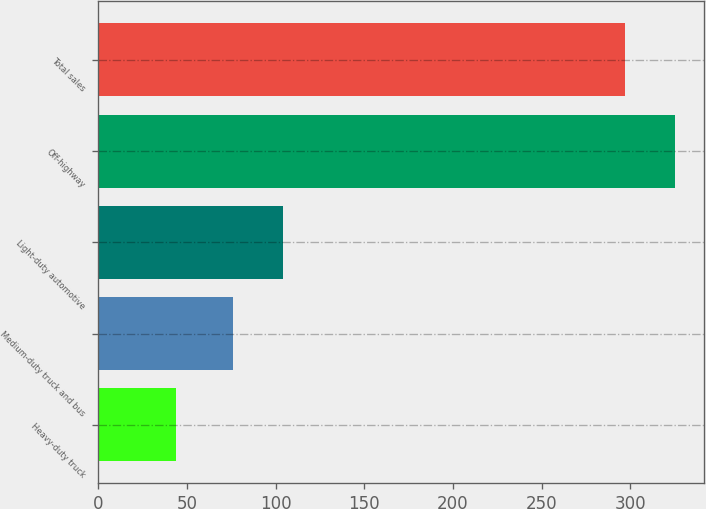Convert chart to OTSL. <chart><loc_0><loc_0><loc_500><loc_500><bar_chart><fcel>Heavy-duty truck<fcel>Medium-duty truck and bus<fcel>Light-duty automotive<fcel>Off-highway<fcel>Total sales<nl><fcel>44<fcel>76<fcel>104.1<fcel>325.1<fcel>297<nl></chart> 